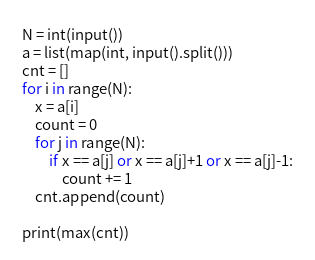Convert code to text. <code><loc_0><loc_0><loc_500><loc_500><_Python_>N = int(input())
a = list(map(int, input().split()))
cnt = []
for i in range(N):
    x = a[i]
    count = 0
    for j in range(N):
        if x == a[j] or x == a[j]+1 or x == a[j]-1:
            count += 1
    cnt.append(count)

print(max(cnt))
</code> 